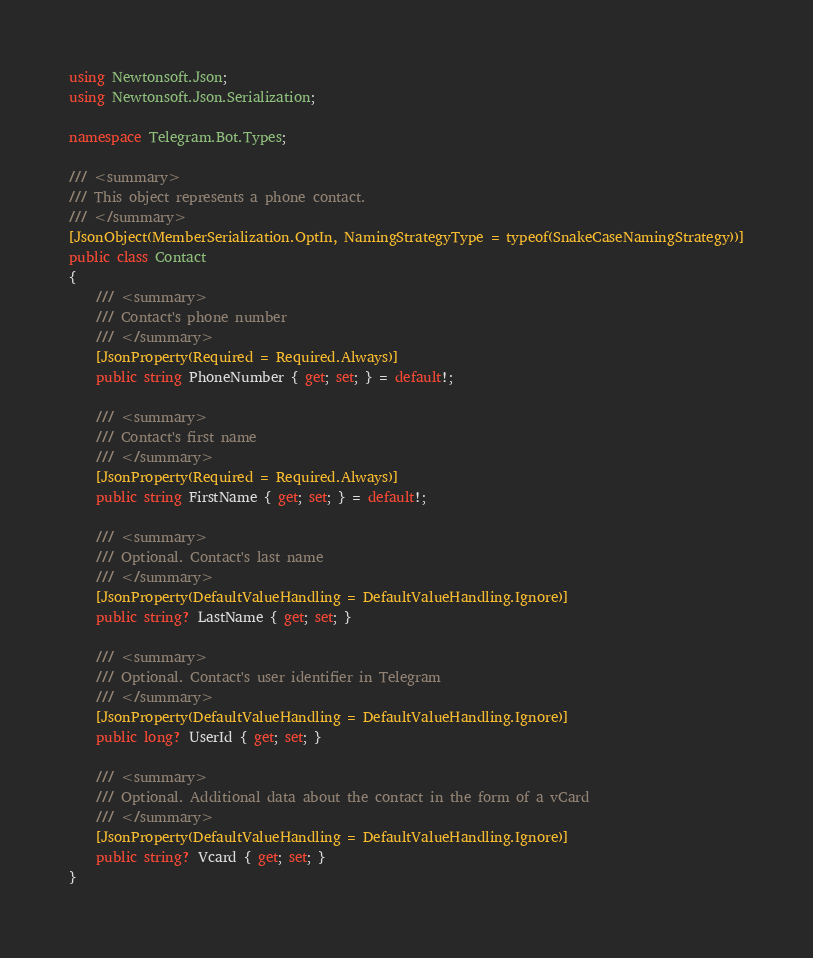<code> <loc_0><loc_0><loc_500><loc_500><_C#_>using Newtonsoft.Json;
using Newtonsoft.Json.Serialization;

namespace Telegram.Bot.Types;

/// <summary>
/// This object represents a phone contact.
/// </summary>
[JsonObject(MemberSerialization.OptIn, NamingStrategyType = typeof(SnakeCaseNamingStrategy))]
public class Contact
{
    /// <summary>
    /// Contact's phone number
    /// </summary>
    [JsonProperty(Required = Required.Always)]
    public string PhoneNumber { get; set; } = default!;

    /// <summary>
    /// Contact's first name
    /// </summary>
    [JsonProperty(Required = Required.Always)]
    public string FirstName { get; set; } = default!;

    /// <summary>
    /// Optional. Contact's last name
    /// </summary>
    [JsonProperty(DefaultValueHandling = DefaultValueHandling.Ignore)]
    public string? LastName { get; set; }

    /// <summary>
    /// Optional. Contact's user identifier in Telegram
    /// </summary>
    [JsonProperty(DefaultValueHandling = DefaultValueHandling.Ignore)]
    public long? UserId { get; set; }

    /// <summary>
    /// Optional. Additional data about the contact in the form of a vCard
    /// </summary>
    [JsonProperty(DefaultValueHandling = DefaultValueHandling.Ignore)]
    public string? Vcard { get; set; }
}</code> 